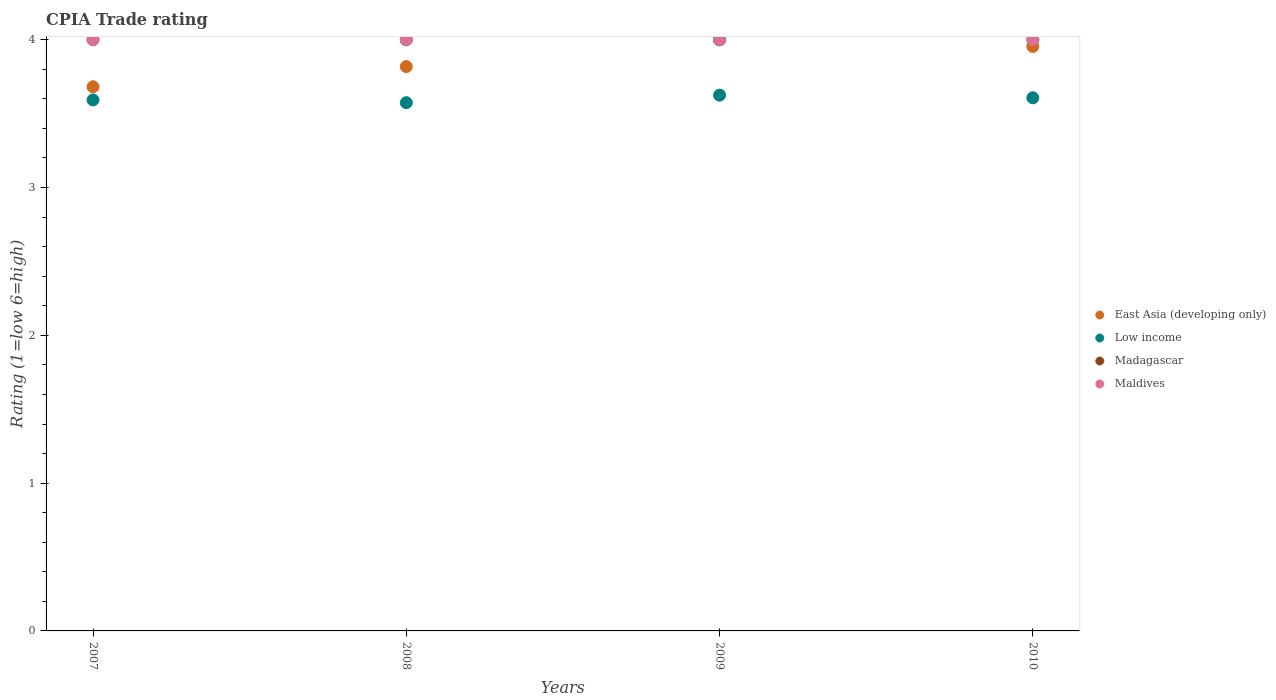How many different coloured dotlines are there?
Your answer should be very brief. 4. What is the CPIA rating in Maldives in 2007?
Your response must be concise. 4. Across all years, what is the maximum CPIA rating in Madagascar?
Provide a short and direct response. 4. Across all years, what is the minimum CPIA rating in Low income?
Offer a very short reply. 3.57. In which year was the CPIA rating in Low income maximum?
Your response must be concise. 2009. In which year was the CPIA rating in Madagascar minimum?
Provide a short and direct response. 2007. What is the total CPIA rating in East Asia (developing only) in the graph?
Give a very brief answer. 15.45. What is the difference between the CPIA rating in Low income in 2008 and that in 2009?
Provide a short and direct response. -0.05. What is the difference between the CPIA rating in Low income in 2010 and the CPIA rating in Madagascar in 2009?
Your answer should be compact. -0.39. What is the average CPIA rating in Low income per year?
Your response must be concise. 3.6. In the year 2008, what is the difference between the CPIA rating in East Asia (developing only) and CPIA rating in Maldives?
Give a very brief answer. -0.18. What is the ratio of the CPIA rating in East Asia (developing only) in 2008 to that in 2009?
Offer a terse response. 0.95. Does the CPIA rating in Maldives monotonically increase over the years?
Make the answer very short. No. Is the CPIA rating in Low income strictly greater than the CPIA rating in Maldives over the years?
Offer a very short reply. No. What is the difference between two consecutive major ticks on the Y-axis?
Offer a terse response. 1. Are the values on the major ticks of Y-axis written in scientific E-notation?
Your response must be concise. No. Where does the legend appear in the graph?
Provide a short and direct response. Center right. How many legend labels are there?
Make the answer very short. 4. How are the legend labels stacked?
Make the answer very short. Vertical. What is the title of the graph?
Offer a terse response. CPIA Trade rating. Does "Armenia" appear as one of the legend labels in the graph?
Ensure brevity in your answer.  No. What is the label or title of the X-axis?
Ensure brevity in your answer.  Years. What is the label or title of the Y-axis?
Ensure brevity in your answer.  Rating (1=low 6=high). What is the Rating (1=low 6=high) of East Asia (developing only) in 2007?
Give a very brief answer. 3.68. What is the Rating (1=low 6=high) of Low income in 2007?
Ensure brevity in your answer.  3.59. What is the Rating (1=low 6=high) in Madagascar in 2007?
Offer a very short reply. 4. What is the Rating (1=low 6=high) of Maldives in 2007?
Make the answer very short. 4. What is the Rating (1=low 6=high) of East Asia (developing only) in 2008?
Your answer should be very brief. 3.82. What is the Rating (1=low 6=high) in Low income in 2008?
Provide a short and direct response. 3.57. What is the Rating (1=low 6=high) in Maldives in 2008?
Provide a succinct answer. 4. What is the Rating (1=low 6=high) of Low income in 2009?
Your answer should be very brief. 3.62. What is the Rating (1=low 6=high) in Madagascar in 2009?
Keep it short and to the point. 4. What is the Rating (1=low 6=high) of East Asia (developing only) in 2010?
Your response must be concise. 3.95. What is the Rating (1=low 6=high) of Low income in 2010?
Your answer should be very brief. 3.61. Across all years, what is the maximum Rating (1=low 6=high) in Low income?
Your answer should be compact. 3.62. Across all years, what is the minimum Rating (1=low 6=high) in East Asia (developing only)?
Your answer should be very brief. 3.68. Across all years, what is the minimum Rating (1=low 6=high) in Low income?
Provide a short and direct response. 3.57. Across all years, what is the minimum Rating (1=low 6=high) of Madagascar?
Offer a terse response. 4. Across all years, what is the minimum Rating (1=low 6=high) of Maldives?
Ensure brevity in your answer.  4. What is the total Rating (1=low 6=high) in East Asia (developing only) in the graph?
Keep it short and to the point. 15.45. What is the total Rating (1=low 6=high) of Low income in the graph?
Provide a short and direct response. 14.4. What is the total Rating (1=low 6=high) in Maldives in the graph?
Ensure brevity in your answer.  16. What is the difference between the Rating (1=low 6=high) of East Asia (developing only) in 2007 and that in 2008?
Ensure brevity in your answer.  -0.14. What is the difference between the Rating (1=low 6=high) in Low income in 2007 and that in 2008?
Offer a very short reply. 0.02. What is the difference between the Rating (1=low 6=high) of East Asia (developing only) in 2007 and that in 2009?
Your answer should be compact. -0.32. What is the difference between the Rating (1=low 6=high) of Low income in 2007 and that in 2009?
Your answer should be very brief. -0.03. What is the difference between the Rating (1=low 6=high) in Madagascar in 2007 and that in 2009?
Your answer should be very brief. 0. What is the difference between the Rating (1=low 6=high) in Maldives in 2007 and that in 2009?
Provide a short and direct response. 0. What is the difference between the Rating (1=low 6=high) in East Asia (developing only) in 2007 and that in 2010?
Your answer should be compact. -0.27. What is the difference between the Rating (1=low 6=high) of Low income in 2007 and that in 2010?
Your answer should be compact. -0.01. What is the difference between the Rating (1=low 6=high) of Madagascar in 2007 and that in 2010?
Keep it short and to the point. 0. What is the difference between the Rating (1=low 6=high) in Maldives in 2007 and that in 2010?
Offer a very short reply. 0. What is the difference between the Rating (1=low 6=high) in East Asia (developing only) in 2008 and that in 2009?
Your response must be concise. -0.18. What is the difference between the Rating (1=low 6=high) of Low income in 2008 and that in 2009?
Offer a terse response. -0.05. What is the difference between the Rating (1=low 6=high) of Maldives in 2008 and that in 2009?
Keep it short and to the point. 0. What is the difference between the Rating (1=low 6=high) of East Asia (developing only) in 2008 and that in 2010?
Give a very brief answer. -0.14. What is the difference between the Rating (1=low 6=high) in Low income in 2008 and that in 2010?
Provide a short and direct response. -0.03. What is the difference between the Rating (1=low 6=high) of Madagascar in 2008 and that in 2010?
Offer a very short reply. 0. What is the difference between the Rating (1=low 6=high) in Maldives in 2008 and that in 2010?
Provide a short and direct response. 0. What is the difference between the Rating (1=low 6=high) in East Asia (developing only) in 2009 and that in 2010?
Provide a short and direct response. 0.05. What is the difference between the Rating (1=low 6=high) in Low income in 2009 and that in 2010?
Your answer should be very brief. 0.02. What is the difference between the Rating (1=low 6=high) in East Asia (developing only) in 2007 and the Rating (1=low 6=high) in Low income in 2008?
Your response must be concise. 0.11. What is the difference between the Rating (1=low 6=high) of East Asia (developing only) in 2007 and the Rating (1=low 6=high) of Madagascar in 2008?
Your answer should be very brief. -0.32. What is the difference between the Rating (1=low 6=high) of East Asia (developing only) in 2007 and the Rating (1=low 6=high) of Maldives in 2008?
Your answer should be very brief. -0.32. What is the difference between the Rating (1=low 6=high) of Low income in 2007 and the Rating (1=low 6=high) of Madagascar in 2008?
Offer a terse response. -0.41. What is the difference between the Rating (1=low 6=high) of Low income in 2007 and the Rating (1=low 6=high) of Maldives in 2008?
Make the answer very short. -0.41. What is the difference between the Rating (1=low 6=high) of Madagascar in 2007 and the Rating (1=low 6=high) of Maldives in 2008?
Provide a short and direct response. 0. What is the difference between the Rating (1=low 6=high) of East Asia (developing only) in 2007 and the Rating (1=low 6=high) of Low income in 2009?
Your answer should be very brief. 0.06. What is the difference between the Rating (1=low 6=high) in East Asia (developing only) in 2007 and the Rating (1=low 6=high) in Madagascar in 2009?
Provide a succinct answer. -0.32. What is the difference between the Rating (1=low 6=high) of East Asia (developing only) in 2007 and the Rating (1=low 6=high) of Maldives in 2009?
Offer a very short reply. -0.32. What is the difference between the Rating (1=low 6=high) in Low income in 2007 and the Rating (1=low 6=high) in Madagascar in 2009?
Your response must be concise. -0.41. What is the difference between the Rating (1=low 6=high) of Low income in 2007 and the Rating (1=low 6=high) of Maldives in 2009?
Offer a very short reply. -0.41. What is the difference between the Rating (1=low 6=high) of Madagascar in 2007 and the Rating (1=low 6=high) of Maldives in 2009?
Offer a very short reply. 0. What is the difference between the Rating (1=low 6=high) in East Asia (developing only) in 2007 and the Rating (1=low 6=high) in Low income in 2010?
Give a very brief answer. 0.07. What is the difference between the Rating (1=low 6=high) in East Asia (developing only) in 2007 and the Rating (1=low 6=high) in Madagascar in 2010?
Your answer should be compact. -0.32. What is the difference between the Rating (1=low 6=high) in East Asia (developing only) in 2007 and the Rating (1=low 6=high) in Maldives in 2010?
Provide a short and direct response. -0.32. What is the difference between the Rating (1=low 6=high) in Low income in 2007 and the Rating (1=low 6=high) in Madagascar in 2010?
Provide a succinct answer. -0.41. What is the difference between the Rating (1=low 6=high) in Low income in 2007 and the Rating (1=low 6=high) in Maldives in 2010?
Keep it short and to the point. -0.41. What is the difference between the Rating (1=low 6=high) of East Asia (developing only) in 2008 and the Rating (1=low 6=high) of Low income in 2009?
Keep it short and to the point. 0.19. What is the difference between the Rating (1=low 6=high) of East Asia (developing only) in 2008 and the Rating (1=low 6=high) of Madagascar in 2009?
Provide a succinct answer. -0.18. What is the difference between the Rating (1=low 6=high) in East Asia (developing only) in 2008 and the Rating (1=low 6=high) in Maldives in 2009?
Offer a very short reply. -0.18. What is the difference between the Rating (1=low 6=high) in Low income in 2008 and the Rating (1=low 6=high) in Madagascar in 2009?
Your answer should be compact. -0.43. What is the difference between the Rating (1=low 6=high) in Low income in 2008 and the Rating (1=low 6=high) in Maldives in 2009?
Offer a very short reply. -0.43. What is the difference between the Rating (1=low 6=high) of Madagascar in 2008 and the Rating (1=low 6=high) of Maldives in 2009?
Offer a very short reply. 0. What is the difference between the Rating (1=low 6=high) in East Asia (developing only) in 2008 and the Rating (1=low 6=high) in Low income in 2010?
Offer a terse response. 0.21. What is the difference between the Rating (1=low 6=high) in East Asia (developing only) in 2008 and the Rating (1=low 6=high) in Madagascar in 2010?
Provide a short and direct response. -0.18. What is the difference between the Rating (1=low 6=high) of East Asia (developing only) in 2008 and the Rating (1=low 6=high) of Maldives in 2010?
Provide a short and direct response. -0.18. What is the difference between the Rating (1=low 6=high) of Low income in 2008 and the Rating (1=low 6=high) of Madagascar in 2010?
Provide a succinct answer. -0.43. What is the difference between the Rating (1=low 6=high) of Low income in 2008 and the Rating (1=low 6=high) of Maldives in 2010?
Offer a very short reply. -0.43. What is the difference between the Rating (1=low 6=high) of Madagascar in 2008 and the Rating (1=low 6=high) of Maldives in 2010?
Offer a very short reply. 0. What is the difference between the Rating (1=low 6=high) of East Asia (developing only) in 2009 and the Rating (1=low 6=high) of Low income in 2010?
Ensure brevity in your answer.  0.39. What is the difference between the Rating (1=low 6=high) of East Asia (developing only) in 2009 and the Rating (1=low 6=high) of Madagascar in 2010?
Your answer should be very brief. 0. What is the difference between the Rating (1=low 6=high) in East Asia (developing only) in 2009 and the Rating (1=low 6=high) in Maldives in 2010?
Give a very brief answer. 0. What is the difference between the Rating (1=low 6=high) in Low income in 2009 and the Rating (1=low 6=high) in Madagascar in 2010?
Make the answer very short. -0.38. What is the difference between the Rating (1=low 6=high) of Low income in 2009 and the Rating (1=low 6=high) of Maldives in 2010?
Offer a very short reply. -0.38. What is the difference between the Rating (1=low 6=high) in Madagascar in 2009 and the Rating (1=low 6=high) in Maldives in 2010?
Keep it short and to the point. 0. What is the average Rating (1=low 6=high) in East Asia (developing only) per year?
Provide a short and direct response. 3.86. What is the average Rating (1=low 6=high) in Low income per year?
Ensure brevity in your answer.  3.6. What is the average Rating (1=low 6=high) in Madagascar per year?
Keep it short and to the point. 4. What is the average Rating (1=low 6=high) in Maldives per year?
Keep it short and to the point. 4. In the year 2007, what is the difference between the Rating (1=low 6=high) in East Asia (developing only) and Rating (1=low 6=high) in Low income?
Make the answer very short. 0.09. In the year 2007, what is the difference between the Rating (1=low 6=high) in East Asia (developing only) and Rating (1=low 6=high) in Madagascar?
Offer a very short reply. -0.32. In the year 2007, what is the difference between the Rating (1=low 6=high) of East Asia (developing only) and Rating (1=low 6=high) of Maldives?
Your response must be concise. -0.32. In the year 2007, what is the difference between the Rating (1=low 6=high) of Low income and Rating (1=low 6=high) of Madagascar?
Keep it short and to the point. -0.41. In the year 2007, what is the difference between the Rating (1=low 6=high) in Low income and Rating (1=low 6=high) in Maldives?
Ensure brevity in your answer.  -0.41. In the year 2008, what is the difference between the Rating (1=low 6=high) in East Asia (developing only) and Rating (1=low 6=high) in Low income?
Make the answer very short. 0.24. In the year 2008, what is the difference between the Rating (1=low 6=high) in East Asia (developing only) and Rating (1=low 6=high) in Madagascar?
Give a very brief answer. -0.18. In the year 2008, what is the difference between the Rating (1=low 6=high) of East Asia (developing only) and Rating (1=low 6=high) of Maldives?
Offer a terse response. -0.18. In the year 2008, what is the difference between the Rating (1=low 6=high) of Low income and Rating (1=low 6=high) of Madagascar?
Make the answer very short. -0.43. In the year 2008, what is the difference between the Rating (1=low 6=high) in Low income and Rating (1=low 6=high) in Maldives?
Your response must be concise. -0.43. In the year 2009, what is the difference between the Rating (1=low 6=high) in East Asia (developing only) and Rating (1=low 6=high) in Low income?
Offer a terse response. 0.38. In the year 2009, what is the difference between the Rating (1=low 6=high) of East Asia (developing only) and Rating (1=low 6=high) of Maldives?
Your answer should be compact. 0. In the year 2009, what is the difference between the Rating (1=low 6=high) in Low income and Rating (1=low 6=high) in Madagascar?
Ensure brevity in your answer.  -0.38. In the year 2009, what is the difference between the Rating (1=low 6=high) in Low income and Rating (1=low 6=high) in Maldives?
Ensure brevity in your answer.  -0.38. In the year 2009, what is the difference between the Rating (1=low 6=high) in Madagascar and Rating (1=low 6=high) in Maldives?
Your response must be concise. 0. In the year 2010, what is the difference between the Rating (1=low 6=high) in East Asia (developing only) and Rating (1=low 6=high) in Low income?
Offer a very short reply. 0.35. In the year 2010, what is the difference between the Rating (1=low 6=high) of East Asia (developing only) and Rating (1=low 6=high) of Madagascar?
Provide a short and direct response. -0.05. In the year 2010, what is the difference between the Rating (1=low 6=high) of East Asia (developing only) and Rating (1=low 6=high) of Maldives?
Your answer should be compact. -0.05. In the year 2010, what is the difference between the Rating (1=low 6=high) in Low income and Rating (1=low 6=high) in Madagascar?
Offer a terse response. -0.39. In the year 2010, what is the difference between the Rating (1=low 6=high) in Low income and Rating (1=low 6=high) in Maldives?
Ensure brevity in your answer.  -0.39. What is the ratio of the Rating (1=low 6=high) of East Asia (developing only) in 2007 to that in 2008?
Ensure brevity in your answer.  0.96. What is the ratio of the Rating (1=low 6=high) of Madagascar in 2007 to that in 2008?
Your answer should be very brief. 1. What is the ratio of the Rating (1=low 6=high) in East Asia (developing only) in 2007 to that in 2009?
Your answer should be compact. 0.92. What is the ratio of the Rating (1=low 6=high) in Madagascar in 2007 to that in 2009?
Provide a succinct answer. 1. What is the ratio of the Rating (1=low 6=high) of Maldives in 2007 to that in 2009?
Your response must be concise. 1. What is the ratio of the Rating (1=low 6=high) in East Asia (developing only) in 2007 to that in 2010?
Your answer should be compact. 0.93. What is the ratio of the Rating (1=low 6=high) of Madagascar in 2007 to that in 2010?
Offer a terse response. 1. What is the ratio of the Rating (1=low 6=high) in East Asia (developing only) in 2008 to that in 2009?
Offer a terse response. 0.95. What is the ratio of the Rating (1=low 6=high) of Maldives in 2008 to that in 2009?
Provide a succinct answer. 1. What is the ratio of the Rating (1=low 6=high) in East Asia (developing only) in 2008 to that in 2010?
Ensure brevity in your answer.  0.97. What is the ratio of the Rating (1=low 6=high) in Low income in 2008 to that in 2010?
Provide a short and direct response. 0.99. What is the ratio of the Rating (1=low 6=high) in Maldives in 2008 to that in 2010?
Give a very brief answer. 1. What is the ratio of the Rating (1=low 6=high) in East Asia (developing only) in 2009 to that in 2010?
Ensure brevity in your answer.  1.01. What is the ratio of the Rating (1=low 6=high) of Madagascar in 2009 to that in 2010?
Your response must be concise. 1. What is the difference between the highest and the second highest Rating (1=low 6=high) of East Asia (developing only)?
Your answer should be compact. 0.05. What is the difference between the highest and the second highest Rating (1=low 6=high) of Low income?
Your answer should be compact. 0.02. What is the difference between the highest and the second highest Rating (1=low 6=high) in Maldives?
Make the answer very short. 0. What is the difference between the highest and the lowest Rating (1=low 6=high) of East Asia (developing only)?
Your answer should be very brief. 0.32. What is the difference between the highest and the lowest Rating (1=low 6=high) of Low income?
Offer a very short reply. 0.05. What is the difference between the highest and the lowest Rating (1=low 6=high) of Madagascar?
Your response must be concise. 0. What is the difference between the highest and the lowest Rating (1=low 6=high) of Maldives?
Provide a succinct answer. 0. 